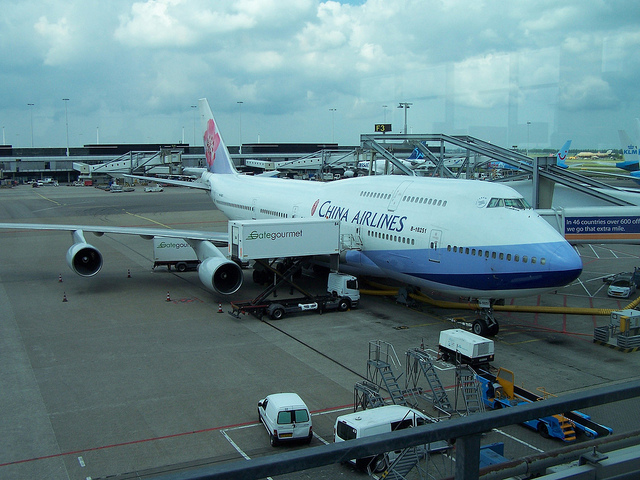Please identify all text content in this image. CHINA AIRLINES Gategourmet 90 45 